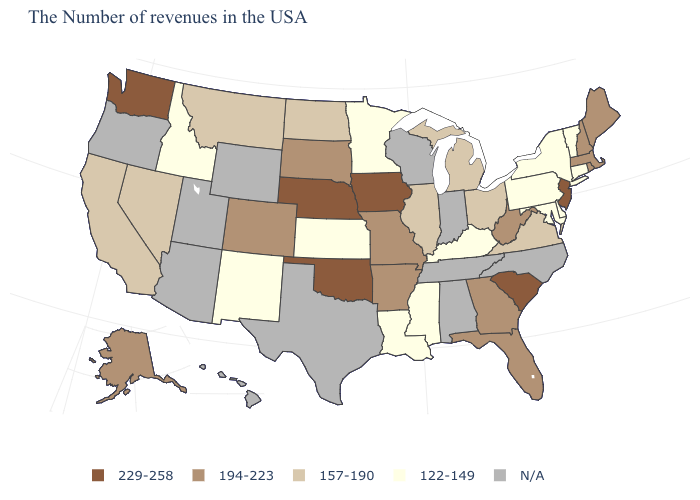Name the states that have a value in the range N/A?
Keep it brief. North Carolina, Indiana, Alabama, Tennessee, Wisconsin, Texas, Wyoming, Utah, Arizona, Oregon, Hawaii. What is the value of Oregon?
Answer briefly. N/A. Does the map have missing data?
Concise answer only. Yes. What is the value of Massachusetts?
Answer briefly. 194-223. Does Nebraska have the highest value in the USA?
Keep it brief. Yes. Does New Hampshire have the lowest value in the Northeast?
Answer briefly. No. Which states have the lowest value in the USA?
Quick response, please. Vermont, Connecticut, New York, Delaware, Maryland, Pennsylvania, Kentucky, Mississippi, Louisiana, Minnesota, Kansas, New Mexico, Idaho. What is the lowest value in states that border South Dakota?
Short answer required. 122-149. Does Oklahoma have the lowest value in the USA?
Answer briefly. No. Is the legend a continuous bar?
Write a very short answer. No. Name the states that have a value in the range 194-223?
Answer briefly. Maine, Massachusetts, Rhode Island, New Hampshire, West Virginia, Florida, Georgia, Missouri, Arkansas, South Dakota, Colorado, Alaska. Among the states that border Mississippi , which have the highest value?
Be succinct. Arkansas. What is the value of West Virginia?
Concise answer only. 194-223. Does the map have missing data?
Quick response, please. Yes. 